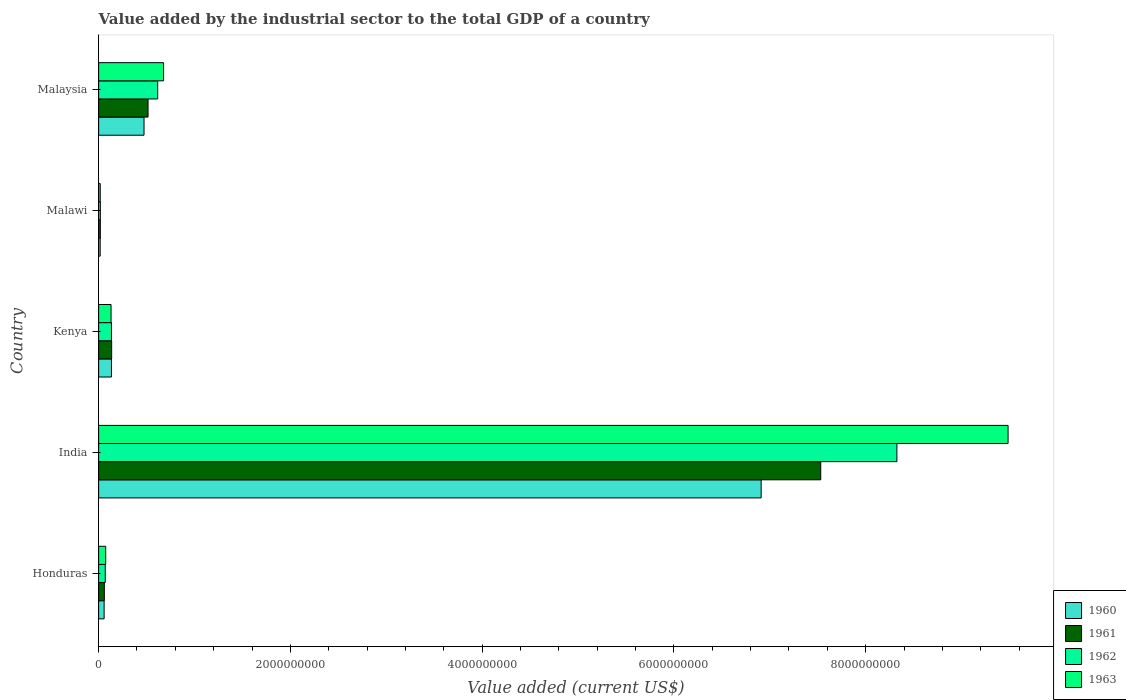How many different coloured bars are there?
Offer a very short reply. 4. How many groups of bars are there?
Provide a succinct answer. 5. Are the number of bars per tick equal to the number of legend labels?
Make the answer very short. Yes. How many bars are there on the 2nd tick from the top?
Your answer should be very brief. 4. How many bars are there on the 2nd tick from the bottom?
Your answer should be compact. 4. What is the label of the 5th group of bars from the top?
Give a very brief answer. Honduras. What is the value added by the industrial sector to the total GDP in 1963 in Kenya?
Provide a succinct answer. 1.30e+08. Across all countries, what is the maximum value added by the industrial sector to the total GDP in 1960?
Keep it short and to the point. 6.91e+09. Across all countries, what is the minimum value added by the industrial sector to the total GDP in 1962?
Provide a succinct answer. 1.78e+07. In which country was the value added by the industrial sector to the total GDP in 1962 maximum?
Offer a very short reply. India. In which country was the value added by the industrial sector to the total GDP in 1963 minimum?
Offer a terse response. Malawi. What is the total value added by the industrial sector to the total GDP in 1961 in the graph?
Make the answer very short. 8.26e+09. What is the difference between the value added by the industrial sector to the total GDP in 1961 in Honduras and that in Malawi?
Make the answer very short. 4.17e+07. What is the difference between the value added by the industrial sector to the total GDP in 1961 in Kenya and the value added by the industrial sector to the total GDP in 1963 in Malawi?
Ensure brevity in your answer.  1.19e+08. What is the average value added by the industrial sector to the total GDP in 1960 per country?
Provide a short and direct response. 1.52e+09. What is the difference between the value added by the industrial sector to the total GDP in 1961 and value added by the industrial sector to the total GDP in 1962 in Malaysia?
Your response must be concise. -1.01e+08. In how many countries, is the value added by the industrial sector to the total GDP in 1962 greater than 6000000000 US$?
Make the answer very short. 1. What is the ratio of the value added by the industrial sector to the total GDP in 1961 in Honduras to that in Malawi?
Offer a very short reply. 3.36. Is the value added by the industrial sector to the total GDP in 1962 in India less than that in Malawi?
Offer a terse response. No. What is the difference between the highest and the second highest value added by the industrial sector to the total GDP in 1960?
Provide a succinct answer. 6.44e+09. What is the difference between the highest and the lowest value added by the industrial sector to the total GDP in 1961?
Your answer should be compact. 7.51e+09. In how many countries, is the value added by the industrial sector to the total GDP in 1960 greater than the average value added by the industrial sector to the total GDP in 1960 taken over all countries?
Provide a short and direct response. 1. Is the sum of the value added by the industrial sector to the total GDP in 1962 in Honduras and India greater than the maximum value added by the industrial sector to the total GDP in 1963 across all countries?
Your response must be concise. No. Is it the case that in every country, the sum of the value added by the industrial sector to the total GDP in 1962 and value added by the industrial sector to the total GDP in 1963 is greater than the sum of value added by the industrial sector to the total GDP in 1961 and value added by the industrial sector to the total GDP in 1960?
Offer a very short reply. No. What does the 4th bar from the bottom in Kenya represents?
Ensure brevity in your answer.  1963. Is it the case that in every country, the sum of the value added by the industrial sector to the total GDP in 1962 and value added by the industrial sector to the total GDP in 1960 is greater than the value added by the industrial sector to the total GDP in 1961?
Offer a very short reply. Yes. What is the difference between two consecutive major ticks on the X-axis?
Provide a succinct answer. 2.00e+09. Are the values on the major ticks of X-axis written in scientific E-notation?
Your answer should be compact. No. Where does the legend appear in the graph?
Give a very brief answer. Bottom right. How are the legend labels stacked?
Offer a very short reply. Vertical. What is the title of the graph?
Your answer should be very brief. Value added by the industrial sector to the total GDP of a country. What is the label or title of the X-axis?
Offer a very short reply. Value added (current US$). What is the Value added (current US$) in 1960 in Honduras?
Offer a terse response. 5.73e+07. What is the Value added (current US$) of 1961 in Honduras?
Your answer should be compact. 5.94e+07. What is the Value added (current US$) in 1962 in Honduras?
Provide a short and direct response. 6.92e+07. What is the Value added (current US$) in 1963 in Honduras?
Give a very brief answer. 7.38e+07. What is the Value added (current US$) in 1960 in India?
Provide a short and direct response. 6.91e+09. What is the Value added (current US$) of 1961 in India?
Your answer should be very brief. 7.53e+09. What is the Value added (current US$) of 1962 in India?
Offer a terse response. 8.33e+09. What is the Value added (current US$) in 1963 in India?
Give a very brief answer. 9.49e+09. What is the Value added (current US$) of 1960 in Kenya?
Make the answer very short. 1.34e+08. What is the Value added (current US$) in 1961 in Kenya?
Provide a succinct answer. 1.36e+08. What is the Value added (current US$) in 1962 in Kenya?
Provide a short and direct response. 1.34e+08. What is the Value added (current US$) in 1963 in Kenya?
Give a very brief answer. 1.30e+08. What is the Value added (current US$) in 1960 in Malawi?
Provide a succinct answer. 1.62e+07. What is the Value added (current US$) of 1961 in Malawi?
Offer a very short reply. 1.76e+07. What is the Value added (current US$) of 1962 in Malawi?
Give a very brief answer. 1.78e+07. What is the Value added (current US$) of 1963 in Malawi?
Offer a terse response. 1.69e+07. What is the Value added (current US$) in 1960 in Malaysia?
Your answer should be very brief. 4.74e+08. What is the Value added (current US$) in 1961 in Malaysia?
Provide a succinct answer. 5.15e+08. What is the Value added (current US$) of 1962 in Malaysia?
Give a very brief answer. 6.16e+08. What is the Value added (current US$) of 1963 in Malaysia?
Ensure brevity in your answer.  6.77e+08. Across all countries, what is the maximum Value added (current US$) of 1960?
Offer a terse response. 6.91e+09. Across all countries, what is the maximum Value added (current US$) in 1961?
Your answer should be compact. 7.53e+09. Across all countries, what is the maximum Value added (current US$) in 1962?
Make the answer very short. 8.33e+09. Across all countries, what is the maximum Value added (current US$) in 1963?
Provide a short and direct response. 9.49e+09. Across all countries, what is the minimum Value added (current US$) in 1960?
Offer a very short reply. 1.62e+07. Across all countries, what is the minimum Value added (current US$) of 1961?
Your answer should be compact. 1.76e+07. Across all countries, what is the minimum Value added (current US$) of 1962?
Provide a succinct answer. 1.78e+07. Across all countries, what is the minimum Value added (current US$) of 1963?
Provide a succinct answer. 1.69e+07. What is the total Value added (current US$) in 1960 in the graph?
Provide a succinct answer. 7.59e+09. What is the total Value added (current US$) in 1961 in the graph?
Your answer should be compact. 8.26e+09. What is the total Value added (current US$) of 1962 in the graph?
Offer a very short reply. 9.16e+09. What is the total Value added (current US$) in 1963 in the graph?
Ensure brevity in your answer.  1.04e+1. What is the difference between the Value added (current US$) of 1960 in Honduras and that in India?
Your response must be concise. -6.85e+09. What is the difference between the Value added (current US$) in 1961 in Honduras and that in India?
Ensure brevity in your answer.  -7.47e+09. What is the difference between the Value added (current US$) of 1962 in Honduras and that in India?
Your response must be concise. -8.26e+09. What is the difference between the Value added (current US$) of 1963 in Honduras and that in India?
Give a very brief answer. -9.41e+09. What is the difference between the Value added (current US$) of 1960 in Honduras and that in Kenya?
Keep it short and to the point. -7.63e+07. What is the difference between the Value added (current US$) of 1961 in Honduras and that in Kenya?
Your answer should be compact. -7.65e+07. What is the difference between the Value added (current US$) of 1962 in Honduras and that in Kenya?
Provide a short and direct response. -6.47e+07. What is the difference between the Value added (current US$) of 1963 in Honduras and that in Kenya?
Provide a short and direct response. -5.57e+07. What is the difference between the Value added (current US$) in 1960 in Honduras and that in Malawi?
Keep it short and to the point. 4.11e+07. What is the difference between the Value added (current US$) in 1961 in Honduras and that in Malawi?
Offer a very short reply. 4.17e+07. What is the difference between the Value added (current US$) of 1962 in Honduras and that in Malawi?
Make the answer very short. 5.14e+07. What is the difference between the Value added (current US$) in 1963 in Honduras and that in Malawi?
Your answer should be compact. 5.69e+07. What is the difference between the Value added (current US$) in 1960 in Honduras and that in Malaysia?
Provide a succinct answer. -4.16e+08. What is the difference between the Value added (current US$) of 1961 in Honduras and that in Malaysia?
Offer a very short reply. -4.56e+08. What is the difference between the Value added (current US$) in 1962 in Honduras and that in Malaysia?
Make the answer very short. -5.47e+08. What is the difference between the Value added (current US$) of 1963 in Honduras and that in Malaysia?
Ensure brevity in your answer.  -6.04e+08. What is the difference between the Value added (current US$) of 1960 in India and that in Kenya?
Your answer should be very brief. 6.78e+09. What is the difference between the Value added (current US$) in 1961 in India and that in Kenya?
Provide a short and direct response. 7.40e+09. What is the difference between the Value added (current US$) in 1962 in India and that in Kenya?
Your answer should be very brief. 8.19e+09. What is the difference between the Value added (current US$) of 1963 in India and that in Kenya?
Your answer should be compact. 9.36e+09. What is the difference between the Value added (current US$) of 1960 in India and that in Malawi?
Your response must be concise. 6.89e+09. What is the difference between the Value added (current US$) of 1961 in India and that in Malawi?
Give a very brief answer. 7.51e+09. What is the difference between the Value added (current US$) in 1962 in India and that in Malawi?
Ensure brevity in your answer.  8.31e+09. What is the difference between the Value added (current US$) in 1963 in India and that in Malawi?
Ensure brevity in your answer.  9.47e+09. What is the difference between the Value added (current US$) in 1960 in India and that in Malaysia?
Your answer should be very brief. 6.44e+09. What is the difference between the Value added (current US$) in 1961 in India and that in Malaysia?
Ensure brevity in your answer.  7.02e+09. What is the difference between the Value added (current US$) of 1962 in India and that in Malaysia?
Your response must be concise. 7.71e+09. What is the difference between the Value added (current US$) of 1963 in India and that in Malaysia?
Give a very brief answer. 8.81e+09. What is the difference between the Value added (current US$) in 1960 in Kenya and that in Malawi?
Keep it short and to the point. 1.17e+08. What is the difference between the Value added (current US$) in 1961 in Kenya and that in Malawi?
Ensure brevity in your answer.  1.18e+08. What is the difference between the Value added (current US$) of 1962 in Kenya and that in Malawi?
Make the answer very short. 1.16e+08. What is the difference between the Value added (current US$) in 1963 in Kenya and that in Malawi?
Provide a succinct answer. 1.13e+08. What is the difference between the Value added (current US$) in 1960 in Kenya and that in Malaysia?
Your answer should be compact. -3.40e+08. What is the difference between the Value added (current US$) in 1961 in Kenya and that in Malaysia?
Your answer should be compact. -3.79e+08. What is the difference between the Value added (current US$) in 1962 in Kenya and that in Malaysia?
Make the answer very short. -4.82e+08. What is the difference between the Value added (current US$) of 1963 in Kenya and that in Malaysia?
Your response must be concise. -5.48e+08. What is the difference between the Value added (current US$) in 1960 in Malawi and that in Malaysia?
Ensure brevity in your answer.  -4.57e+08. What is the difference between the Value added (current US$) in 1961 in Malawi and that in Malaysia?
Your response must be concise. -4.98e+08. What is the difference between the Value added (current US$) of 1962 in Malawi and that in Malaysia?
Make the answer very short. -5.98e+08. What is the difference between the Value added (current US$) of 1963 in Malawi and that in Malaysia?
Keep it short and to the point. -6.61e+08. What is the difference between the Value added (current US$) of 1960 in Honduras and the Value added (current US$) of 1961 in India?
Your answer should be compact. -7.47e+09. What is the difference between the Value added (current US$) in 1960 in Honduras and the Value added (current US$) in 1962 in India?
Give a very brief answer. -8.27e+09. What is the difference between the Value added (current US$) in 1960 in Honduras and the Value added (current US$) in 1963 in India?
Provide a succinct answer. -9.43e+09. What is the difference between the Value added (current US$) of 1961 in Honduras and the Value added (current US$) of 1962 in India?
Provide a succinct answer. -8.27e+09. What is the difference between the Value added (current US$) in 1961 in Honduras and the Value added (current US$) in 1963 in India?
Give a very brief answer. -9.43e+09. What is the difference between the Value added (current US$) of 1962 in Honduras and the Value added (current US$) of 1963 in India?
Keep it short and to the point. -9.42e+09. What is the difference between the Value added (current US$) in 1960 in Honduras and the Value added (current US$) in 1961 in Kenya?
Provide a short and direct response. -7.86e+07. What is the difference between the Value added (current US$) of 1960 in Honduras and the Value added (current US$) of 1962 in Kenya?
Offer a very short reply. -7.66e+07. What is the difference between the Value added (current US$) in 1960 in Honduras and the Value added (current US$) in 1963 in Kenya?
Provide a succinct answer. -7.22e+07. What is the difference between the Value added (current US$) of 1961 in Honduras and the Value added (current US$) of 1962 in Kenya?
Offer a very short reply. -7.46e+07. What is the difference between the Value added (current US$) of 1961 in Honduras and the Value added (current US$) of 1963 in Kenya?
Make the answer very short. -7.02e+07. What is the difference between the Value added (current US$) in 1962 in Honduras and the Value added (current US$) in 1963 in Kenya?
Make the answer very short. -6.03e+07. What is the difference between the Value added (current US$) of 1960 in Honduras and the Value added (current US$) of 1961 in Malawi?
Give a very brief answer. 3.97e+07. What is the difference between the Value added (current US$) of 1960 in Honduras and the Value added (current US$) of 1962 in Malawi?
Keep it short and to the point. 3.95e+07. What is the difference between the Value added (current US$) of 1960 in Honduras and the Value added (current US$) of 1963 in Malawi?
Offer a terse response. 4.04e+07. What is the difference between the Value added (current US$) of 1961 in Honduras and the Value added (current US$) of 1962 in Malawi?
Make the answer very short. 4.16e+07. What is the difference between the Value added (current US$) of 1961 in Honduras and the Value added (current US$) of 1963 in Malawi?
Provide a succinct answer. 4.24e+07. What is the difference between the Value added (current US$) of 1962 in Honduras and the Value added (current US$) of 1963 in Malawi?
Make the answer very short. 5.23e+07. What is the difference between the Value added (current US$) of 1960 in Honduras and the Value added (current US$) of 1961 in Malaysia?
Make the answer very short. -4.58e+08. What is the difference between the Value added (current US$) in 1960 in Honduras and the Value added (current US$) in 1962 in Malaysia?
Make the answer very short. -5.59e+08. What is the difference between the Value added (current US$) of 1960 in Honduras and the Value added (current US$) of 1963 in Malaysia?
Your answer should be very brief. -6.20e+08. What is the difference between the Value added (current US$) of 1961 in Honduras and the Value added (current US$) of 1962 in Malaysia?
Your response must be concise. -5.57e+08. What is the difference between the Value added (current US$) of 1961 in Honduras and the Value added (current US$) of 1963 in Malaysia?
Your answer should be very brief. -6.18e+08. What is the difference between the Value added (current US$) in 1962 in Honduras and the Value added (current US$) in 1963 in Malaysia?
Your response must be concise. -6.08e+08. What is the difference between the Value added (current US$) in 1960 in India and the Value added (current US$) in 1961 in Kenya?
Keep it short and to the point. 6.77e+09. What is the difference between the Value added (current US$) of 1960 in India and the Value added (current US$) of 1962 in Kenya?
Make the answer very short. 6.78e+09. What is the difference between the Value added (current US$) in 1960 in India and the Value added (current US$) in 1963 in Kenya?
Ensure brevity in your answer.  6.78e+09. What is the difference between the Value added (current US$) in 1961 in India and the Value added (current US$) in 1962 in Kenya?
Keep it short and to the point. 7.40e+09. What is the difference between the Value added (current US$) of 1961 in India and the Value added (current US$) of 1963 in Kenya?
Offer a terse response. 7.40e+09. What is the difference between the Value added (current US$) in 1962 in India and the Value added (current US$) in 1963 in Kenya?
Ensure brevity in your answer.  8.20e+09. What is the difference between the Value added (current US$) of 1960 in India and the Value added (current US$) of 1961 in Malawi?
Keep it short and to the point. 6.89e+09. What is the difference between the Value added (current US$) in 1960 in India and the Value added (current US$) in 1962 in Malawi?
Provide a succinct answer. 6.89e+09. What is the difference between the Value added (current US$) in 1960 in India and the Value added (current US$) in 1963 in Malawi?
Give a very brief answer. 6.89e+09. What is the difference between the Value added (current US$) in 1961 in India and the Value added (current US$) in 1962 in Malawi?
Give a very brief answer. 7.51e+09. What is the difference between the Value added (current US$) in 1961 in India and the Value added (current US$) in 1963 in Malawi?
Provide a succinct answer. 7.51e+09. What is the difference between the Value added (current US$) of 1962 in India and the Value added (current US$) of 1963 in Malawi?
Give a very brief answer. 8.31e+09. What is the difference between the Value added (current US$) in 1960 in India and the Value added (current US$) in 1961 in Malaysia?
Provide a succinct answer. 6.39e+09. What is the difference between the Value added (current US$) of 1960 in India and the Value added (current US$) of 1962 in Malaysia?
Your answer should be very brief. 6.29e+09. What is the difference between the Value added (current US$) in 1960 in India and the Value added (current US$) in 1963 in Malaysia?
Offer a terse response. 6.23e+09. What is the difference between the Value added (current US$) of 1961 in India and the Value added (current US$) of 1962 in Malaysia?
Your response must be concise. 6.92e+09. What is the difference between the Value added (current US$) of 1961 in India and the Value added (current US$) of 1963 in Malaysia?
Offer a very short reply. 6.85e+09. What is the difference between the Value added (current US$) of 1962 in India and the Value added (current US$) of 1963 in Malaysia?
Give a very brief answer. 7.65e+09. What is the difference between the Value added (current US$) in 1960 in Kenya and the Value added (current US$) in 1961 in Malawi?
Provide a short and direct response. 1.16e+08. What is the difference between the Value added (current US$) in 1960 in Kenya and the Value added (current US$) in 1962 in Malawi?
Offer a very short reply. 1.16e+08. What is the difference between the Value added (current US$) of 1960 in Kenya and the Value added (current US$) of 1963 in Malawi?
Your answer should be compact. 1.17e+08. What is the difference between the Value added (current US$) of 1961 in Kenya and the Value added (current US$) of 1962 in Malawi?
Make the answer very short. 1.18e+08. What is the difference between the Value added (current US$) of 1961 in Kenya and the Value added (current US$) of 1963 in Malawi?
Ensure brevity in your answer.  1.19e+08. What is the difference between the Value added (current US$) of 1962 in Kenya and the Value added (current US$) of 1963 in Malawi?
Give a very brief answer. 1.17e+08. What is the difference between the Value added (current US$) in 1960 in Kenya and the Value added (current US$) in 1961 in Malaysia?
Keep it short and to the point. -3.82e+08. What is the difference between the Value added (current US$) in 1960 in Kenya and the Value added (current US$) in 1962 in Malaysia?
Make the answer very short. -4.82e+08. What is the difference between the Value added (current US$) in 1960 in Kenya and the Value added (current US$) in 1963 in Malaysia?
Provide a short and direct response. -5.44e+08. What is the difference between the Value added (current US$) of 1961 in Kenya and the Value added (current US$) of 1962 in Malaysia?
Your response must be concise. -4.80e+08. What is the difference between the Value added (current US$) of 1961 in Kenya and the Value added (current US$) of 1963 in Malaysia?
Offer a very short reply. -5.42e+08. What is the difference between the Value added (current US$) of 1962 in Kenya and the Value added (current US$) of 1963 in Malaysia?
Your response must be concise. -5.44e+08. What is the difference between the Value added (current US$) in 1960 in Malawi and the Value added (current US$) in 1961 in Malaysia?
Offer a terse response. -4.99e+08. What is the difference between the Value added (current US$) of 1960 in Malawi and the Value added (current US$) of 1962 in Malaysia?
Ensure brevity in your answer.  -6.00e+08. What is the difference between the Value added (current US$) of 1960 in Malawi and the Value added (current US$) of 1963 in Malaysia?
Offer a terse response. -6.61e+08. What is the difference between the Value added (current US$) in 1961 in Malawi and the Value added (current US$) in 1962 in Malaysia?
Provide a succinct answer. -5.98e+08. What is the difference between the Value added (current US$) of 1961 in Malawi and the Value added (current US$) of 1963 in Malaysia?
Your answer should be very brief. -6.60e+08. What is the difference between the Value added (current US$) in 1962 in Malawi and the Value added (current US$) in 1963 in Malaysia?
Your response must be concise. -6.60e+08. What is the average Value added (current US$) of 1960 per country?
Your answer should be very brief. 1.52e+09. What is the average Value added (current US$) of 1961 per country?
Keep it short and to the point. 1.65e+09. What is the average Value added (current US$) in 1962 per country?
Give a very brief answer. 1.83e+09. What is the average Value added (current US$) of 1963 per country?
Offer a very short reply. 2.08e+09. What is the difference between the Value added (current US$) in 1960 and Value added (current US$) in 1961 in Honduras?
Your answer should be very brief. -2.05e+06. What is the difference between the Value added (current US$) in 1960 and Value added (current US$) in 1962 in Honduras?
Ensure brevity in your answer.  -1.19e+07. What is the difference between the Value added (current US$) of 1960 and Value added (current US$) of 1963 in Honduras?
Give a very brief answer. -1.65e+07. What is the difference between the Value added (current US$) in 1961 and Value added (current US$) in 1962 in Honduras?
Give a very brief answer. -9.85e+06. What is the difference between the Value added (current US$) in 1961 and Value added (current US$) in 1963 in Honduras?
Ensure brevity in your answer.  -1.44e+07. What is the difference between the Value added (current US$) in 1962 and Value added (current US$) in 1963 in Honduras?
Your answer should be compact. -4.60e+06. What is the difference between the Value added (current US$) in 1960 and Value added (current US$) in 1961 in India?
Give a very brief answer. -6.21e+08. What is the difference between the Value added (current US$) in 1960 and Value added (current US$) in 1962 in India?
Your answer should be very brief. -1.42e+09. What is the difference between the Value added (current US$) of 1960 and Value added (current US$) of 1963 in India?
Offer a very short reply. -2.58e+09. What is the difference between the Value added (current US$) in 1961 and Value added (current US$) in 1962 in India?
Ensure brevity in your answer.  -7.94e+08. What is the difference between the Value added (current US$) in 1961 and Value added (current US$) in 1963 in India?
Ensure brevity in your answer.  -1.95e+09. What is the difference between the Value added (current US$) of 1962 and Value added (current US$) of 1963 in India?
Keep it short and to the point. -1.16e+09. What is the difference between the Value added (current US$) of 1960 and Value added (current US$) of 1961 in Kenya?
Ensure brevity in your answer.  -2.25e+06. What is the difference between the Value added (current US$) of 1960 and Value added (current US$) of 1962 in Kenya?
Provide a succinct answer. -2.94e+05. What is the difference between the Value added (current US$) of 1960 and Value added (current US$) of 1963 in Kenya?
Make the answer very short. 4.12e+06. What is the difference between the Value added (current US$) of 1961 and Value added (current US$) of 1962 in Kenya?
Your answer should be compact. 1.96e+06. What is the difference between the Value added (current US$) of 1961 and Value added (current US$) of 1963 in Kenya?
Give a very brief answer. 6.37e+06. What is the difference between the Value added (current US$) of 1962 and Value added (current US$) of 1963 in Kenya?
Make the answer very short. 4.41e+06. What is the difference between the Value added (current US$) in 1960 and Value added (current US$) in 1961 in Malawi?
Provide a succinct answer. -1.40e+06. What is the difference between the Value added (current US$) of 1960 and Value added (current US$) of 1962 in Malawi?
Ensure brevity in your answer.  -1.54e+06. What is the difference between the Value added (current US$) in 1960 and Value added (current US$) in 1963 in Malawi?
Keep it short and to the point. -7.00e+05. What is the difference between the Value added (current US$) in 1961 and Value added (current US$) in 1962 in Malawi?
Offer a very short reply. -1.40e+05. What is the difference between the Value added (current US$) of 1961 and Value added (current US$) of 1963 in Malawi?
Provide a succinct answer. 7.00e+05. What is the difference between the Value added (current US$) in 1962 and Value added (current US$) in 1963 in Malawi?
Your answer should be very brief. 8.40e+05. What is the difference between the Value added (current US$) of 1960 and Value added (current US$) of 1961 in Malaysia?
Your response must be concise. -4.19e+07. What is the difference between the Value added (current US$) in 1960 and Value added (current US$) in 1962 in Malaysia?
Give a very brief answer. -1.43e+08. What is the difference between the Value added (current US$) in 1960 and Value added (current US$) in 1963 in Malaysia?
Your answer should be compact. -2.04e+08. What is the difference between the Value added (current US$) in 1961 and Value added (current US$) in 1962 in Malaysia?
Keep it short and to the point. -1.01e+08. What is the difference between the Value added (current US$) in 1961 and Value added (current US$) in 1963 in Malaysia?
Keep it short and to the point. -1.62e+08. What is the difference between the Value added (current US$) in 1962 and Value added (current US$) in 1963 in Malaysia?
Your answer should be compact. -6.14e+07. What is the ratio of the Value added (current US$) of 1960 in Honduras to that in India?
Offer a very short reply. 0.01. What is the ratio of the Value added (current US$) in 1961 in Honduras to that in India?
Your answer should be very brief. 0.01. What is the ratio of the Value added (current US$) in 1962 in Honduras to that in India?
Your response must be concise. 0.01. What is the ratio of the Value added (current US$) of 1963 in Honduras to that in India?
Ensure brevity in your answer.  0.01. What is the ratio of the Value added (current US$) of 1960 in Honduras to that in Kenya?
Your answer should be very brief. 0.43. What is the ratio of the Value added (current US$) in 1961 in Honduras to that in Kenya?
Your answer should be very brief. 0.44. What is the ratio of the Value added (current US$) of 1962 in Honduras to that in Kenya?
Provide a succinct answer. 0.52. What is the ratio of the Value added (current US$) in 1963 in Honduras to that in Kenya?
Your answer should be compact. 0.57. What is the ratio of the Value added (current US$) of 1960 in Honduras to that in Malawi?
Provide a short and direct response. 3.53. What is the ratio of the Value added (current US$) of 1961 in Honduras to that in Malawi?
Ensure brevity in your answer.  3.36. What is the ratio of the Value added (current US$) of 1962 in Honduras to that in Malawi?
Your answer should be compact. 3.89. What is the ratio of the Value added (current US$) in 1963 in Honduras to that in Malawi?
Your answer should be compact. 4.36. What is the ratio of the Value added (current US$) of 1960 in Honduras to that in Malaysia?
Your response must be concise. 0.12. What is the ratio of the Value added (current US$) in 1961 in Honduras to that in Malaysia?
Your response must be concise. 0.12. What is the ratio of the Value added (current US$) of 1962 in Honduras to that in Malaysia?
Give a very brief answer. 0.11. What is the ratio of the Value added (current US$) in 1963 in Honduras to that in Malaysia?
Your answer should be very brief. 0.11. What is the ratio of the Value added (current US$) in 1960 in India to that in Kenya?
Provide a succinct answer. 51.7. What is the ratio of the Value added (current US$) of 1961 in India to that in Kenya?
Keep it short and to the point. 55.42. What is the ratio of the Value added (current US$) of 1962 in India to that in Kenya?
Your response must be concise. 62.16. What is the ratio of the Value added (current US$) in 1963 in India to that in Kenya?
Your answer should be compact. 73.23. What is the ratio of the Value added (current US$) of 1960 in India to that in Malawi?
Your answer should be very brief. 425.49. What is the ratio of the Value added (current US$) in 1961 in India to that in Malawi?
Your response must be concise. 426.94. What is the ratio of the Value added (current US$) in 1962 in India to that in Malawi?
Offer a terse response. 468.26. What is the ratio of the Value added (current US$) of 1963 in India to that in Malawi?
Offer a terse response. 559.94. What is the ratio of the Value added (current US$) of 1960 in India to that in Malaysia?
Keep it short and to the point. 14.59. What is the ratio of the Value added (current US$) of 1961 in India to that in Malaysia?
Offer a very short reply. 14.61. What is the ratio of the Value added (current US$) in 1962 in India to that in Malaysia?
Keep it short and to the point. 13.51. What is the ratio of the Value added (current US$) in 1963 in India to that in Malaysia?
Give a very brief answer. 14. What is the ratio of the Value added (current US$) in 1960 in Kenya to that in Malawi?
Your answer should be very brief. 8.23. What is the ratio of the Value added (current US$) in 1961 in Kenya to that in Malawi?
Offer a terse response. 7.7. What is the ratio of the Value added (current US$) of 1962 in Kenya to that in Malawi?
Keep it short and to the point. 7.53. What is the ratio of the Value added (current US$) in 1963 in Kenya to that in Malawi?
Provide a succinct answer. 7.65. What is the ratio of the Value added (current US$) of 1960 in Kenya to that in Malaysia?
Your response must be concise. 0.28. What is the ratio of the Value added (current US$) in 1961 in Kenya to that in Malaysia?
Provide a succinct answer. 0.26. What is the ratio of the Value added (current US$) in 1962 in Kenya to that in Malaysia?
Your answer should be very brief. 0.22. What is the ratio of the Value added (current US$) of 1963 in Kenya to that in Malaysia?
Your response must be concise. 0.19. What is the ratio of the Value added (current US$) of 1960 in Malawi to that in Malaysia?
Keep it short and to the point. 0.03. What is the ratio of the Value added (current US$) in 1961 in Malawi to that in Malaysia?
Offer a very short reply. 0.03. What is the ratio of the Value added (current US$) of 1962 in Malawi to that in Malaysia?
Your answer should be very brief. 0.03. What is the ratio of the Value added (current US$) in 1963 in Malawi to that in Malaysia?
Make the answer very short. 0.03. What is the difference between the highest and the second highest Value added (current US$) of 1960?
Offer a very short reply. 6.44e+09. What is the difference between the highest and the second highest Value added (current US$) in 1961?
Your answer should be very brief. 7.02e+09. What is the difference between the highest and the second highest Value added (current US$) of 1962?
Provide a succinct answer. 7.71e+09. What is the difference between the highest and the second highest Value added (current US$) in 1963?
Ensure brevity in your answer.  8.81e+09. What is the difference between the highest and the lowest Value added (current US$) in 1960?
Provide a succinct answer. 6.89e+09. What is the difference between the highest and the lowest Value added (current US$) in 1961?
Your response must be concise. 7.51e+09. What is the difference between the highest and the lowest Value added (current US$) in 1962?
Offer a very short reply. 8.31e+09. What is the difference between the highest and the lowest Value added (current US$) of 1963?
Give a very brief answer. 9.47e+09. 